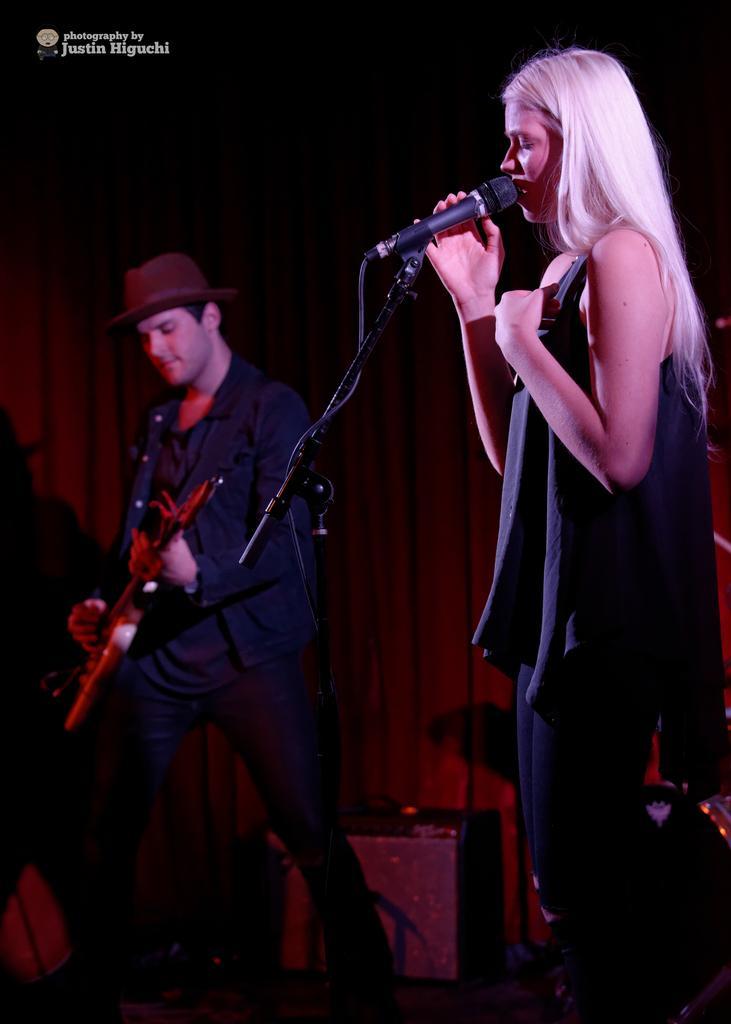Can you describe this image briefly? In this image I can see a man and a woman are standing. I can also see he is holding a guitar and wearing a cap. Here I can see she is holding a mic. 